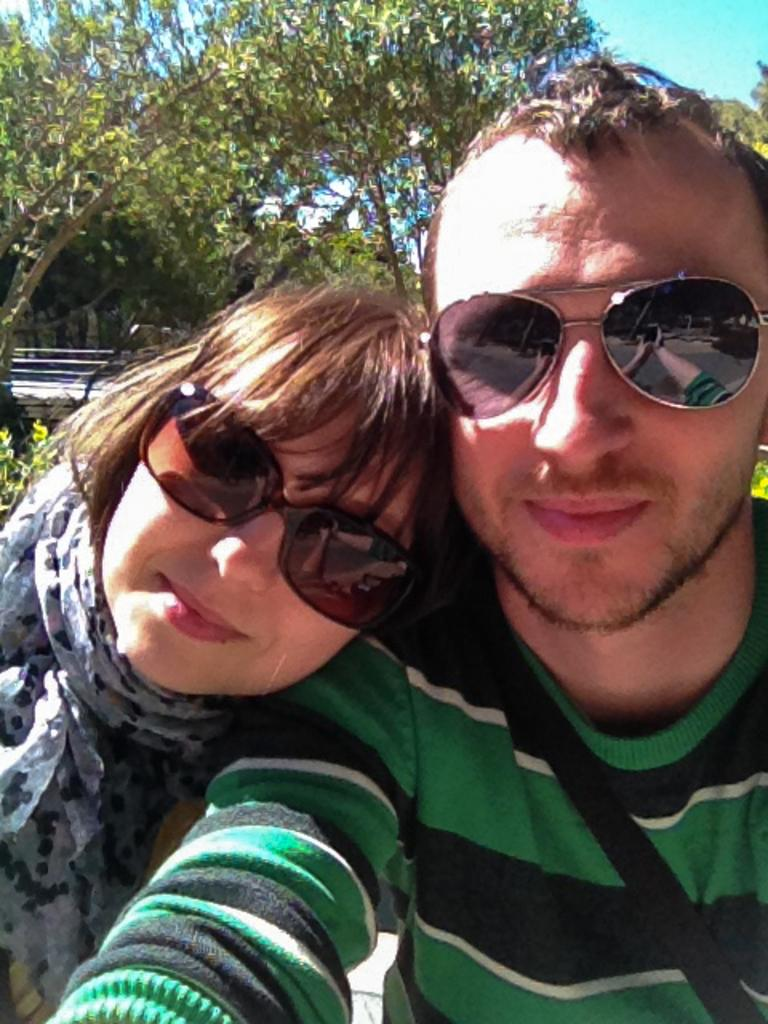How many people are in the foreground of the picture? There are two persons in the foreground of the picture. What are the persons wearing? The persons are wearing goggles. What can be seen in the background of the picture? There is sky, trees, and other objects visible in the background of the picture. Can you see any rabbits playing with soap in the image? There are no rabbits or soap present in the image. What type of army is depicted in the image? There is no army depicted in the image; it features two persons wearing goggles and a background with sky, trees, and other objects. 